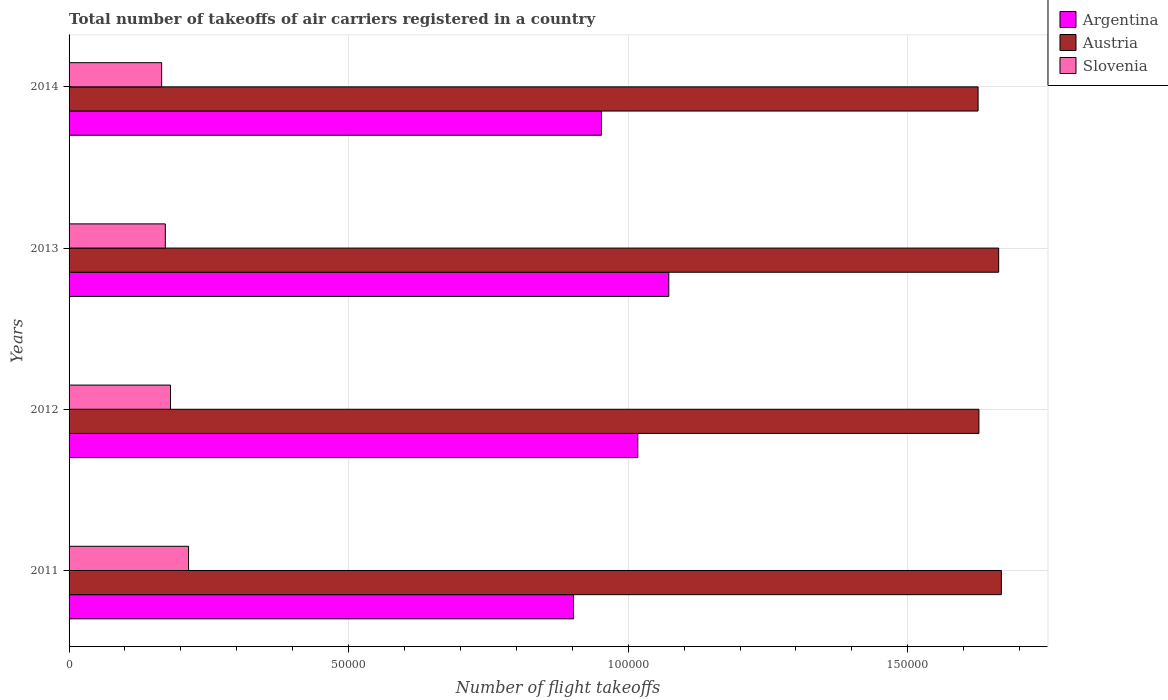How many different coloured bars are there?
Make the answer very short. 3. How many bars are there on the 3rd tick from the top?
Your answer should be compact. 3. How many bars are there on the 3rd tick from the bottom?
Provide a short and direct response. 3. What is the label of the 4th group of bars from the top?
Make the answer very short. 2011. In how many cases, is the number of bars for a given year not equal to the number of legend labels?
Provide a succinct answer. 0. What is the total number of flight takeoffs in Argentina in 2011?
Provide a succinct answer. 9.02e+04. Across all years, what is the maximum total number of flight takeoffs in Austria?
Your response must be concise. 1.67e+05. Across all years, what is the minimum total number of flight takeoffs in Argentina?
Your answer should be compact. 9.02e+04. In which year was the total number of flight takeoffs in Austria maximum?
Give a very brief answer. 2011. In which year was the total number of flight takeoffs in Slovenia minimum?
Provide a short and direct response. 2014. What is the total total number of flight takeoffs in Argentina in the graph?
Your answer should be compact. 3.94e+05. What is the difference between the total number of flight takeoffs in Slovenia in 2011 and that in 2012?
Your response must be concise. 3229. What is the difference between the total number of flight takeoffs in Austria in 2011 and the total number of flight takeoffs in Argentina in 2013?
Your answer should be compact. 5.95e+04. What is the average total number of flight takeoffs in Argentina per year?
Keep it short and to the point. 9.86e+04. In the year 2013, what is the difference between the total number of flight takeoffs in Slovenia and total number of flight takeoffs in Argentina?
Offer a terse response. -9.00e+04. What is the ratio of the total number of flight takeoffs in Austria in 2012 to that in 2013?
Give a very brief answer. 0.98. Is the difference between the total number of flight takeoffs in Slovenia in 2011 and 2014 greater than the difference between the total number of flight takeoffs in Argentina in 2011 and 2014?
Offer a terse response. Yes. What is the difference between the highest and the second highest total number of flight takeoffs in Argentina?
Offer a terse response. 5537.54. What is the difference between the highest and the lowest total number of flight takeoffs in Slovenia?
Provide a succinct answer. 4813. In how many years, is the total number of flight takeoffs in Slovenia greater than the average total number of flight takeoffs in Slovenia taken over all years?
Provide a succinct answer. 1. Is the sum of the total number of flight takeoffs in Slovenia in 2012 and 2013 greater than the maximum total number of flight takeoffs in Argentina across all years?
Your answer should be very brief. No. What does the 1st bar from the top in 2012 represents?
Make the answer very short. Slovenia. What does the 1st bar from the bottom in 2011 represents?
Provide a succinct answer. Argentina. Are all the bars in the graph horizontal?
Offer a terse response. Yes. How many years are there in the graph?
Make the answer very short. 4. Does the graph contain grids?
Ensure brevity in your answer.  Yes. Where does the legend appear in the graph?
Offer a terse response. Top right. How are the legend labels stacked?
Offer a very short reply. Vertical. What is the title of the graph?
Your answer should be compact. Total number of takeoffs of air carriers registered in a country. What is the label or title of the X-axis?
Give a very brief answer. Number of flight takeoffs. What is the label or title of the Y-axis?
Your response must be concise. Years. What is the Number of flight takeoffs of Argentina in 2011?
Offer a very short reply. 9.02e+04. What is the Number of flight takeoffs of Austria in 2011?
Your answer should be compact. 1.67e+05. What is the Number of flight takeoffs of Slovenia in 2011?
Your answer should be compact. 2.14e+04. What is the Number of flight takeoffs of Argentina in 2012?
Ensure brevity in your answer.  1.02e+05. What is the Number of flight takeoffs in Austria in 2012?
Keep it short and to the point. 1.63e+05. What is the Number of flight takeoffs of Slovenia in 2012?
Provide a succinct answer. 1.81e+04. What is the Number of flight takeoffs of Argentina in 2013?
Keep it short and to the point. 1.07e+05. What is the Number of flight takeoffs of Austria in 2013?
Give a very brief answer. 1.66e+05. What is the Number of flight takeoffs in Slovenia in 2013?
Your response must be concise. 1.72e+04. What is the Number of flight takeoffs in Argentina in 2014?
Keep it short and to the point. 9.52e+04. What is the Number of flight takeoffs in Austria in 2014?
Ensure brevity in your answer.  1.63e+05. What is the Number of flight takeoffs in Slovenia in 2014?
Offer a terse response. 1.66e+04. Across all years, what is the maximum Number of flight takeoffs of Argentina?
Provide a short and direct response. 1.07e+05. Across all years, what is the maximum Number of flight takeoffs of Austria?
Keep it short and to the point. 1.67e+05. Across all years, what is the maximum Number of flight takeoffs in Slovenia?
Give a very brief answer. 2.14e+04. Across all years, what is the minimum Number of flight takeoffs of Argentina?
Your answer should be very brief. 9.02e+04. Across all years, what is the minimum Number of flight takeoffs of Austria?
Your response must be concise. 1.63e+05. Across all years, what is the minimum Number of flight takeoffs in Slovenia?
Your answer should be very brief. 1.66e+04. What is the total Number of flight takeoffs of Argentina in the graph?
Ensure brevity in your answer.  3.94e+05. What is the total Number of flight takeoffs of Austria in the graph?
Your answer should be very brief. 6.58e+05. What is the total Number of flight takeoffs of Slovenia in the graph?
Your response must be concise. 7.33e+04. What is the difference between the Number of flight takeoffs of Argentina in 2011 and that in 2012?
Offer a very short reply. -1.15e+04. What is the difference between the Number of flight takeoffs in Austria in 2011 and that in 2012?
Provide a short and direct response. 4014.26. What is the difference between the Number of flight takeoffs in Slovenia in 2011 and that in 2012?
Your answer should be compact. 3229. What is the difference between the Number of flight takeoffs in Argentina in 2011 and that in 2013?
Offer a very short reply. -1.70e+04. What is the difference between the Number of flight takeoffs in Austria in 2011 and that in 2013?
Offer a very short reply. 480.37. What is the difference between the Number of flight takeoffs of Slovenia in 2011 and that in 2013?
Give a very brief answer. 4158. What is the difference between the Number of flight takeoffs of Argentina in 2011 and that in 2014?
Offer a terse response. -4997.16. What is the difference between the Number of flight takeoffs of Austria in 2011 and that in 2014?
Keep it short and to the point. 4163.1. What is the difference between the Number of flight takeoffs of Slovenia in 2011 and that in 2014?
Provide a short and direct response. 4813. What is the difference between the Number of flight takeoffs in Argentina in 2012 and that in 2013?
Make the answer very short. -5537.54. What is the difference between the Number of flight takeoffs of Austria in 2012 and that in 2013?
Make the answer very short. -3533.89. What is the difference between the Number of flight takeoffs of Slovenia in 2012 and that in 2013?
Provide a short and direct response. 929. What is the difference between the Number of flight takeoffs in Argentina in 2012 and that in 2014?
Make the answer very short. 6504.59. What is the difference between the Number of flight takeoffs of Austria in 2012 and that in 2014?
Your answer should be compact. 148.84. What is the difference between the Number of flight takeoffs in Slovenia in 2012 and that in 2014?
Your answer should be compact. 1584. What is the difference between the Number of flight takeoffs of Argentina in 2013 and that in 2014?
Your response must be concise. 1.20e+04. What is the difference between the Number of flight takeoffs of Austria in 2013 and that in 2014?
Make the answer very short. 3682.73. What is the difference between the Number of flight takeoffs of Slovenia in 2013 and that in 2014?
Provide a short and direct response. 655. What is the difference between the Number of flight takeoffs of Argentina in 2011 and the Number of flight takeoffs of Austria in 2012?
Make the answer very short. -7.25e+04. What is the difference between the Number of flight takeoffs of Argentina in 2011 and the Number of flight takeoffs of Slovenia in 2012?
Make the answer very short. 7.21e+04. What is the difference between the Number of flight takeoffs in Austria in 2011 and the Number of flight takeoffs in Slovenia in 2012?
Your response must be concise. 1.49e+05. What is the difference between the Number of flight takeoffs of Argentina in 2011 and the Number of flight takeoffs of Austria in 2013?
Ensure brevity in your answer.  -7.60e+04. What is the difference between the Number of flight takeoffs of Argentina in 2011 and the Number of flight takeoffs of Slovenia in 2013?
Ensure brevity in your answer.  7.30e+04. What is the difference between the Number of flight takeoffs in Austria in 2011 and the Number of flight takeoffs in Slovenia in 2013?
Your response must be concise. 1.50e+05. What is the difference between the Number of flight takeoffs in Argentina in 2011 and the Number of flight takeoffs in Austria in 2014?
Offer a terse response. -7.24e+04. What is the difference between the Number of flight takeoffs in Argentina in 2011 and the Number of flight takeoffs in Slovenia in 2014?
Provide a short and direct response. 7.37e+04. What is the difference between the Number of flight takeoffs of Austria in 2011 and the Number of flight takeoffs of Slovenia in 2014?
Ensure brevity in your answer.  1.50e+05. What is the difference between the Number of flight takeoffs of Argentina in 2012 and the Number of flight takeoffs of Austria in 2013?
Provide a short and direct response. -6.45e+04. What is the difference between the Number of flight takeoffs of Argentina in 2012 and the Number of flight takeoffs of Slovenia in 2013?
Provide a succinct answer. 8.45e+04. What is the difference between the Number of flight takeoffs in Austria in 2012 and the Number of flight takeoffs in Slovenia in 2013?
Your answer should be compact. 1.46e+05. What is the difference between the Number of flight takeoffs in Argentina in 2012 and the Number of flight takeoffs in Austria in 2014?
Your response must be concise. -6.09e+04. What is the difference between the Number of flight takeoffs in Argentina in 2012 and the Number of flight takeoffs in Slovenia in 2014?
Ensure brevity in your answer.  8.52e+04. What is the difference between the Number of flight takeoffs of Austria in 2012 and the Number of flight takeoffs of Slovenia in 2014?
Your response must be concise. 1.46e+05. What is the difference between the Number of flight takeoffs of Argentina in 2013 and the Number of flight takeoffs of Austria in 2014?
Your response must be concise. -5.53e+04. What is the difference between the Number of flight takeoffs in Argentina in 2013 and the Number of flight takeoffs in Slovenia in 2014?
Offer a terse response. 9.07e+04. What is the difference between the Number of flight takeoffs in Austria in 2013 and the Number of flight takeoffs in Slovenia in 2014?
Give a very brief answer. 1.50e+05. What is the average Number of flight takeoffs in Argentina per year?
Your answer should be very brief. 9.86e+04. What is the average Number of flight takeoffs of Austria per year?
Offer a terse response. 1.65e+05. What is the average Number of flight takeoffs of Slovenia per year?
Provide a short and direct response. 1.83e+04. In the year 2011, what is the difference between the Number of flight takeoffs in Argentina and Number of flight takeoffs in Austria?
Your response must be concise. -7.65e+04. In the year 2011, what is the difference between the Number of flight takeoffs in Argentina and Number of flight takeoffs in Slovenia?
Your answer should be very brief. 6.88e+04. In the year 2011, what is the difference between the Number of flight takeoffs of Austria and Number of flight takeoffs of Slovenia?
Your answer should be compact. 1.45e+05. In the year 2012, what is the difference between the Number of flight takeoffs of Argentina and Number of flight takeoffs of Austria?
Give a very brief answer. -6.10e+04. In the year 2012, what is the difference between the Number of flight takeoffs in Argentina and Number of flight takeoffs in Slovenia?
Provide a short and direct response. 8.36e+04. In the year 2012, what is the difference between the Number of flight takeoffs in Austria and Number of flight takeoffs in Slovenia?
Offer a very short reply. 1.45e+05. In the year 2013, what is the difference between the Number of flight takeoffs of Argentina and Number of flight takeoffs of Austria?
Your answer should be very brief. -5.90e+04. In the year 2013, what is the difference between the Number of flight takeoffs in Argentina and Number of flight takeoffs in Slovenia?
Offer a terse response. 9.00e+04. In the year 2013, what is the difference between the Number of flight takeoffs in Austria and Number of flight takeoffs in Slovenia?
Ensure brevity in your answer.  1.49e+05. In the year 2014, what is the difference between the Number of flight takeoffs in Argentina and Number of flight takeoffs in Austria?
Provide a short and direct response. -6.74e+04. In the year 2014, what is the difference between the Number of flight takeoffs of Argentina and Number of flight takeoffs of Slovenia?
Provide a succinct answer. 7.87e+04. In the year 2014, what is the difference between the Number of flight takeoffs in Austria and Number of flight takeoffs in Slovenia?
Offer a terse response. 1.46e+05. What is the ratio of the Number of flight takeoffs of Argentina in 2011 to that in 2012?
Provide a succinct answer. 0.89. What is the ratio of the Number of flight takeoffs in Austria in 2011 to that in 2012?
Give a very brief answer. 1.02. What is the ratio of the Number of flight takeoffs in Slovenia in 2011 to that in 2012?
Give a very brief answer. 1.18. What is the ratio of the Number of flight takeoffs in Argentina in 2011 to that in 2013?
Your answer should be compact. 0.84. What is the ratio of the Number of flight takeoffs in Austria in 2011 to that in 2013?
Offer a terse response. 1. What is the ratio of the Number of flight takeoffs in Slovenia in 2011 to that in 2013?
Your response must be concise. 1.24. What is the ratio of the Number of flight takeoffs of Argentina in 2011 to that in 2014?
Offer a terse response. 0.95. What is the ratio of the Number of flight takeoffs in Austria in 2011 to that in 2014?
Provide a succinct answer. 1.03. What is the ratio of the Number of flight takeoffs of Slovenia in 2011 to that in 2014?
Your answer should be very brief. 1.29. What is the ratio of the Number of flight takeoffs of Argentina in 2012 to that in 2013?
Your answer should be compact. 0.95. What is the ratio of the Number of flight takeoffs in Austria in 2012 to that in 2013?
Give a very brief answer. 0.98. What is the ratio of the Number of flight takeoffs in Slovenia in 2012 to that in 2013?
Offer a terse response. 1.05. What is the ratio of the Number of flight takeoffs in Argentina in 2012 to that in 2014?
Provide a succinct answer. 1.07. What is the ratio of the Number of flight takeoffs in Austria in 2012 to that in 2014?
Give a very brief answer. 1. What is the ratio of the Number of flight takeoffs in Slovenia in 2012 to that in 2014?
Offer a very short reply. 1.1. What is the ratio of the Number of flight takeoffs in Argentina in 2013 to that in 2014?
Your answer should be very brief. 1.13. What is the ratio of the Number of flight takeoffs of Austria in 2013 to that in 2014?
Make the answer very short. 1.02. What is the ratio of the Number of flight takeoffs of Slovenia in 2013 to that in 2014?
Offer a very short reply. 1.04. What is the difference between the highest and the second highest Number of flight takeoffs of Argentina?
Make the answer very short. 5537.54. What is the difference between the highest and the second highest Number of flight takeoffs in Austria?
Give a very brief answer. 480.37. What is the difference between the highest and the second highest Number of flight takeoffs in Slovenia?
Your answer should be compact. 3229. What is the difference between the highest and the lowest Number of flight takeoffs in Argentina?
Make the answer very short. 1.70e+04. What is the difference between the highest and the lowest Number of flight takeoffs in Austria?
Give a very brief answer. 4163.1. What is the difference between the highest and the lowest Number of flight takeoffs in Slovenia?
Offer a very short reply. 4813. 